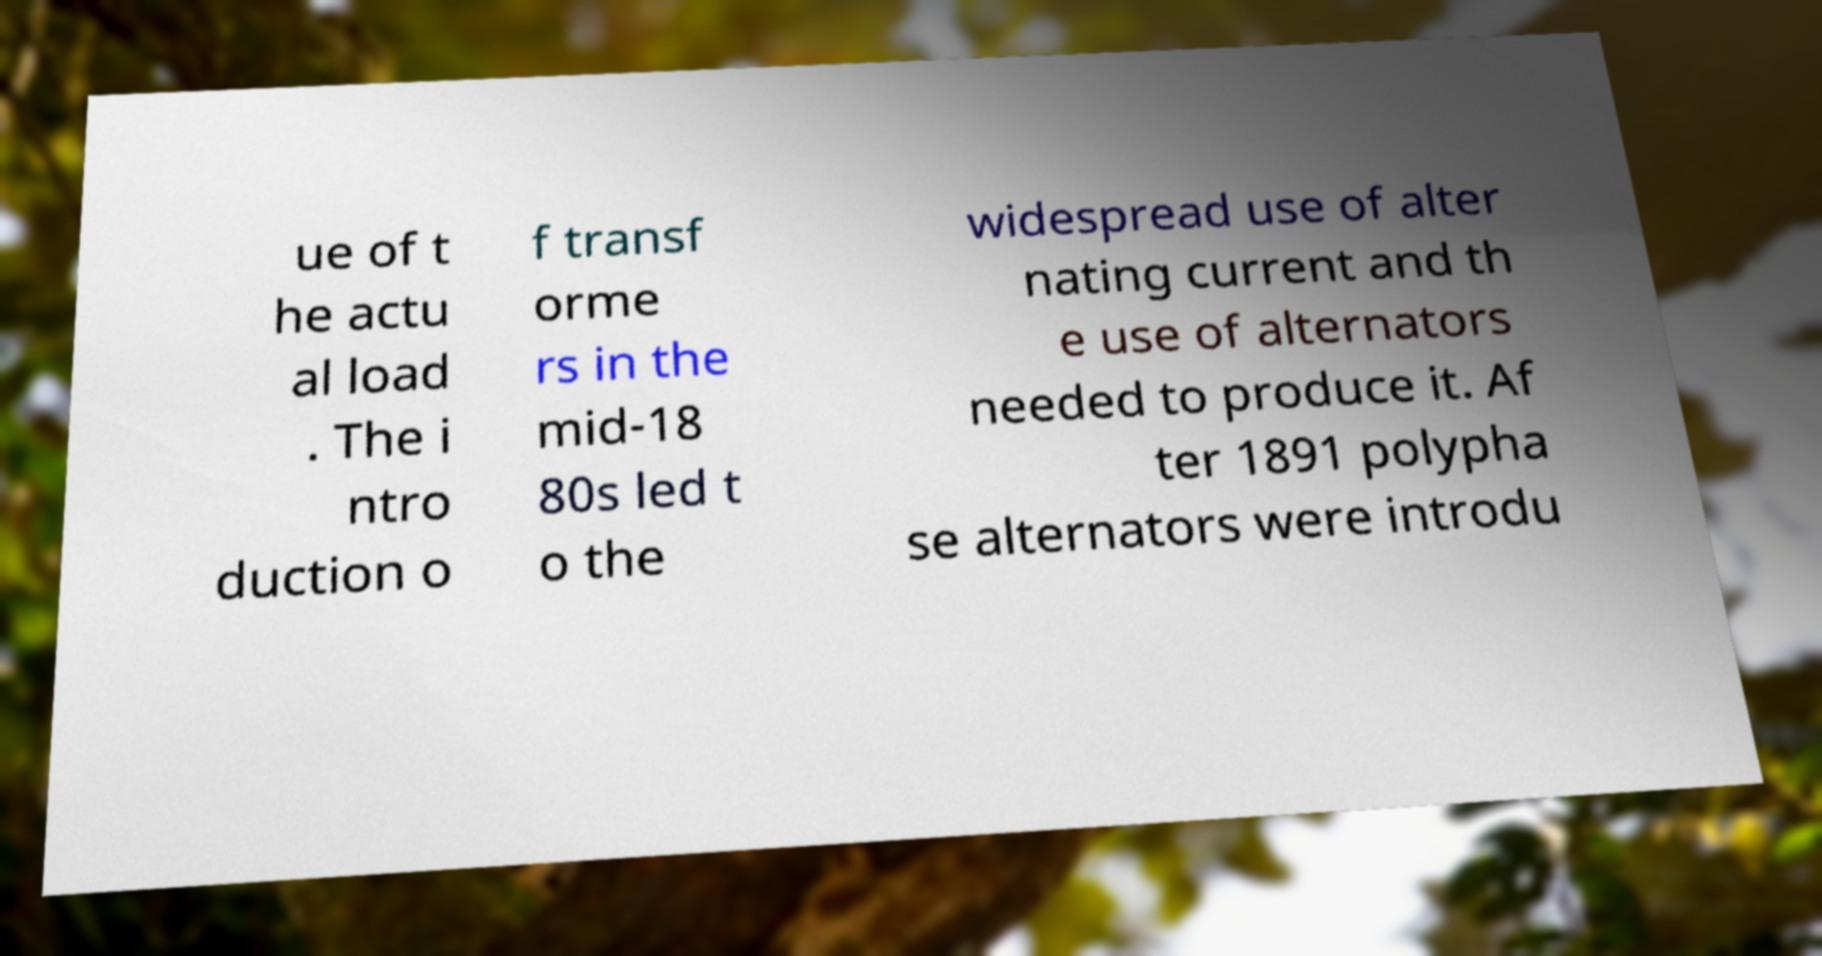There's text embedded in this image that I need extracted. Can you transcribe it verbatim? ue of t he actu al load . The i ntro duction o f transf orme rs in the mid-18 80s led t o the widespread use of alter nating current and th e use of alternators needed to produce it. Af ter 1891 polypha se alternators were introdu 